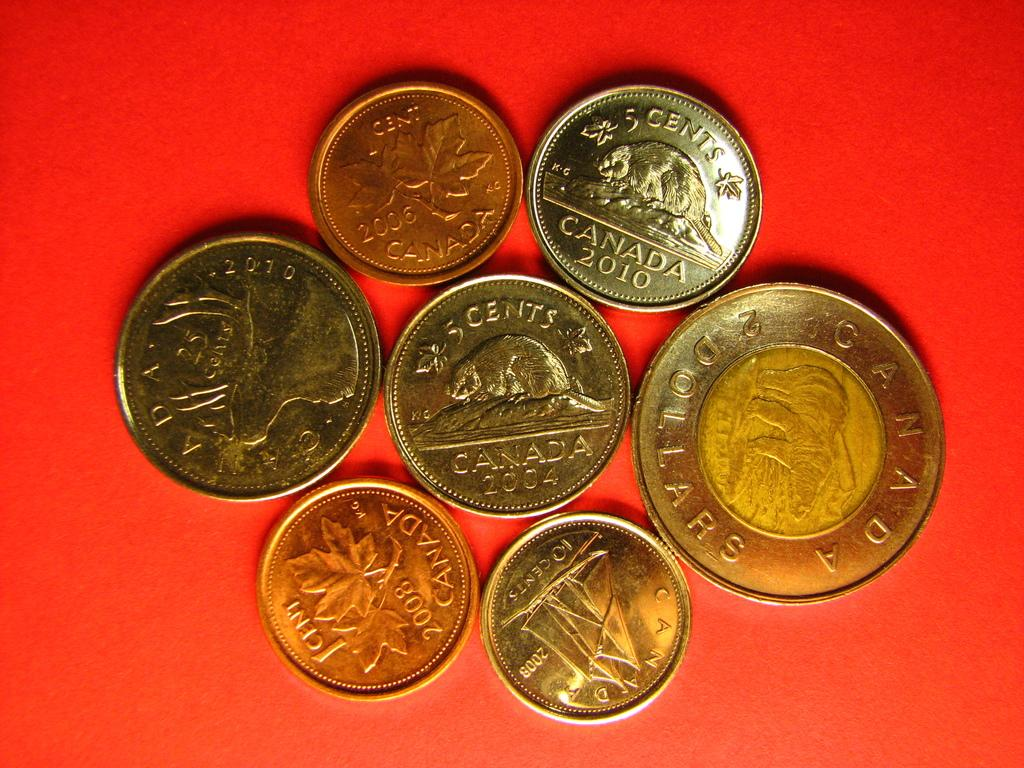<image>
Give a short and clear explanation of the subsequent image. Many coins from Canada are on a red surface. 